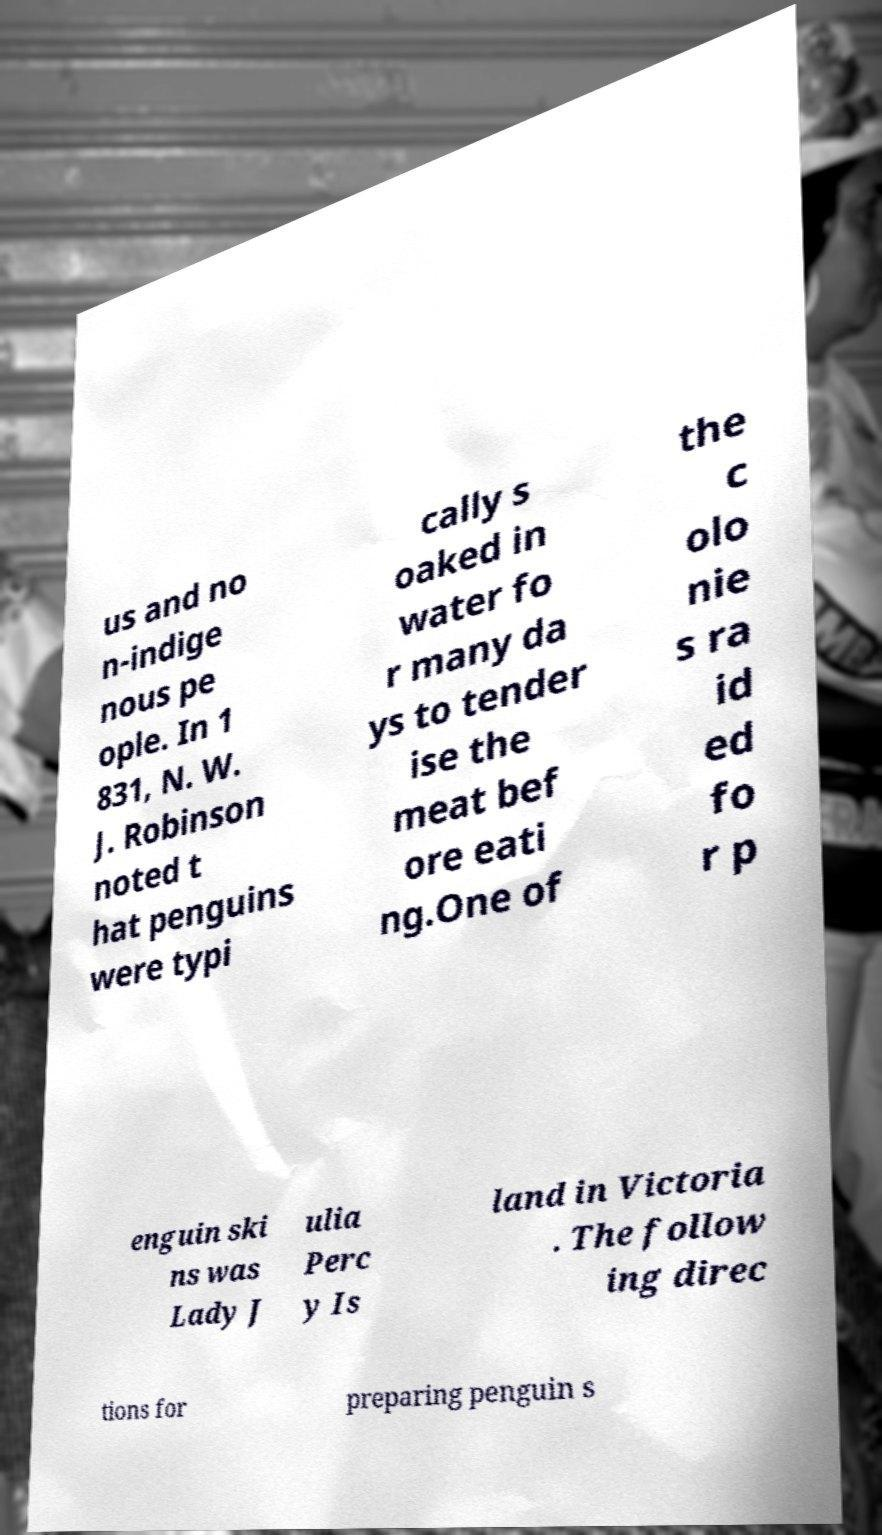Can you read and provide the text displayed in the image?This photo seems to have some interesting text. Can you extract and type it out for me? us and no n-indige nous pe ople. In 1 831, N. W. J. Robinson noted t hat penguins were typi cally s oaked in water fo r many da ys to tender ise the meat bef ore eati ng.One of the c olo nie s ra id ed fo r p enguin ski ns was Lady J ulia Perc y Is land in Victoria . The follow ing direc tions for preparing penguin s 